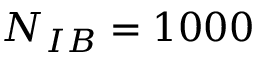<formula> <loc_0><loc_0><loc_500><loc_500>N _ { I B } = 1 0 0 0</formula> 